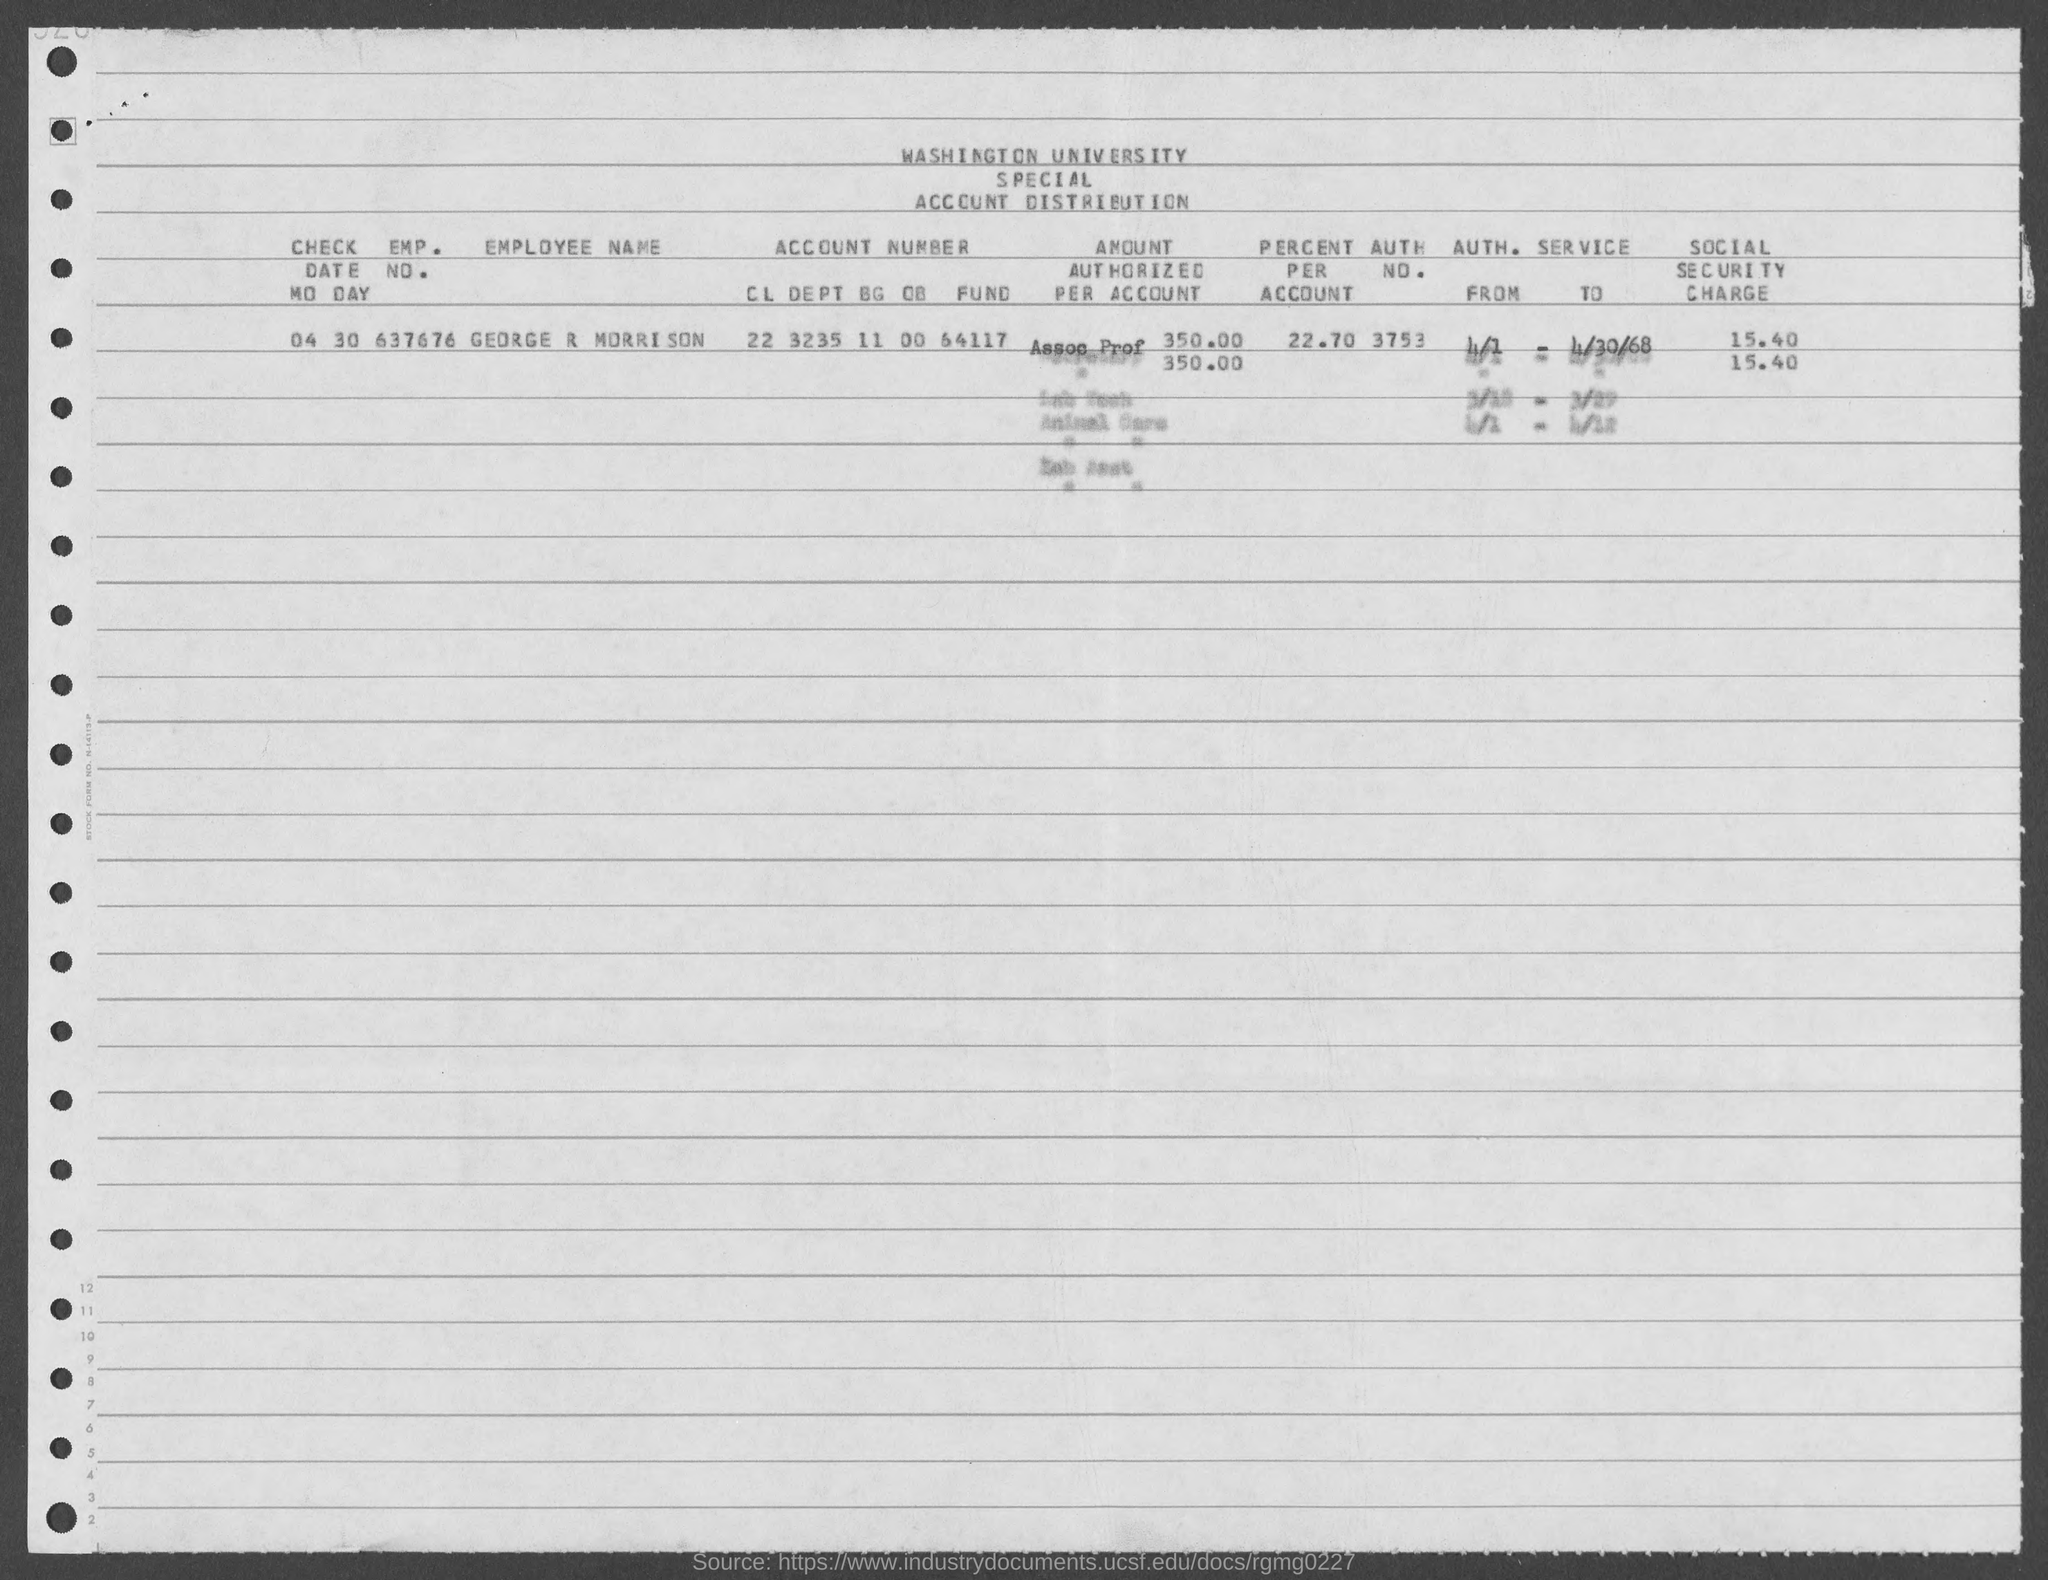What is the emp. no. of george r morrison ?
Ensure brevity in your answer.  637676. What is the percent per account of george r morrison ?
Keep it short and to the point. 22.70. What is the auth. no. of george r morrison ?
Make the answer very short. 3753. What is the check date mo day?
Ensure brevity in your answer.  04 30. 